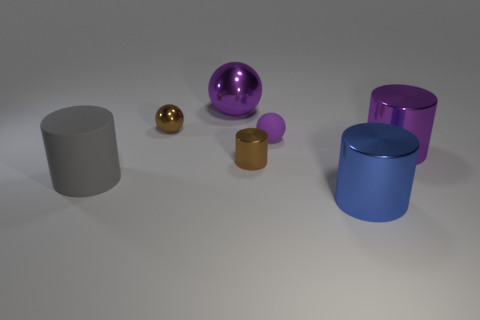Add 2 large purple balls. How many objects exist? 9 Subtract all big blue shiny cylinders. How many cylinders are left? 3 Subtract all purple cylinders. How many purple spheres are left? 2 Subtract all gray cylinders. How many cylinders are left? 3 Subtract all cylinders. How many objects are left? 3 Subtract 0 red spheres. How many objects are left? 7 Subtract 1 cylinders. How many cylinders are left? 3 Subtract all green balls. Subtract all blue cylinders. How many balls are left? 3 Subtract all purple cylinders. Subtract all small metallic cylinders. How many objects are left? 5 Add 7 gray rubber things. How many gray rubber things are left? 8 